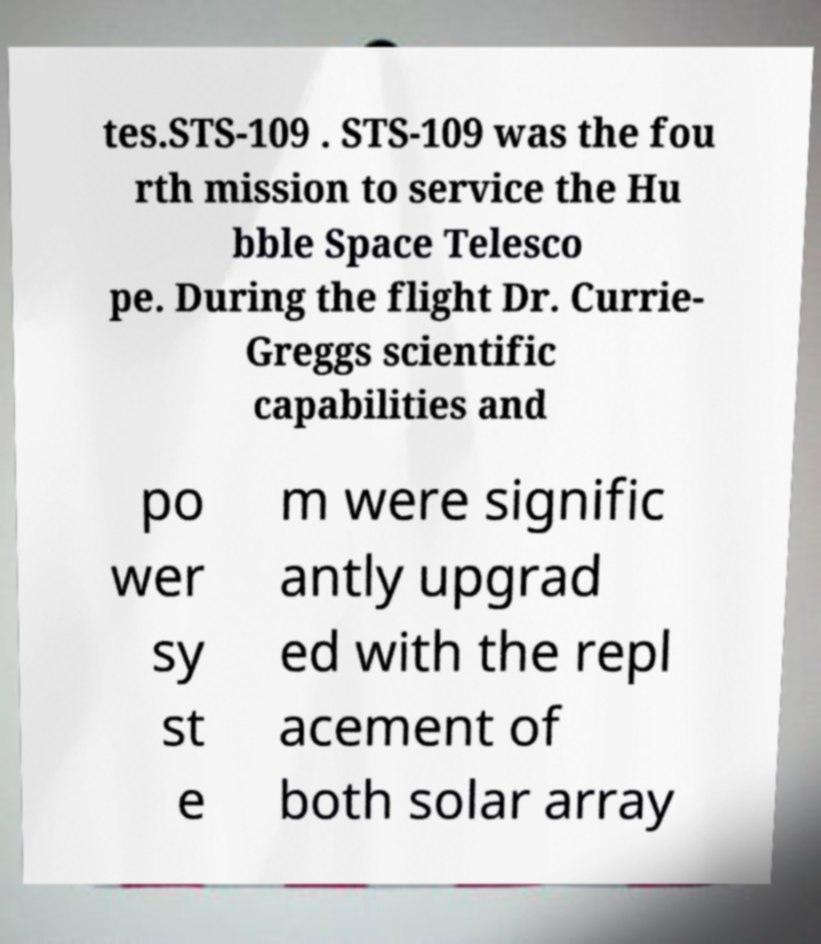For documentation purposes, I need the text within this image transcribed. Could you provide that? tes.STS-109 . STS-109 was the fou rth mission to service the Hu bble Space Telesco pe. During the flight Dr. Currie- Greggs scientific capabilities and po wer sy st e m were signific antly upgrad ed with the repl acement of both solar array 